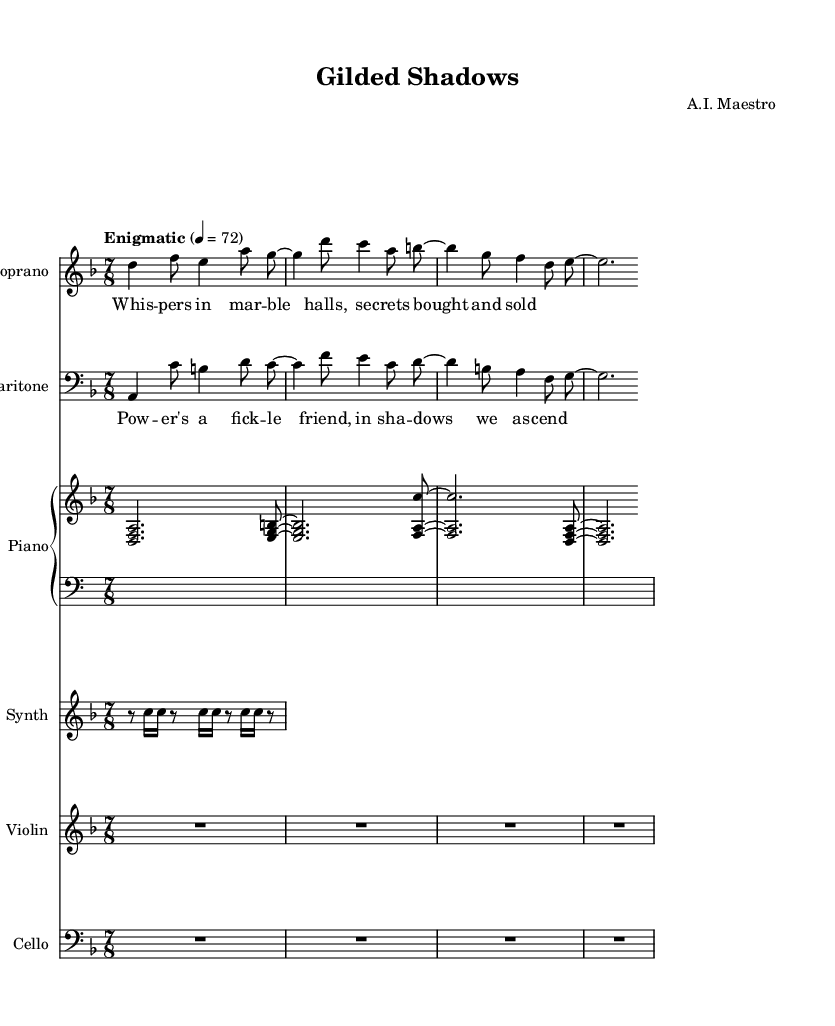What is the key signature of this music? The key signature is indicated by the information "d minor" in the global variable section, which typically outlines the key. D minor has one flat (B flat).
Answer: D minor What is the time signature of this music? The time signature is specified as "7/8" in the global section, which is a compound time signature showing there are seven eighth notes in each measure.
Answer: 7/8 What is the tempo marking for this piece? The tempo marking is found in the global section where it states "Enigmatic" followed by "4 = 72," indicating the speed at which the music should be played.
Answer: Enigmatic 4 = 72 Which instrument has a synthesizer part? By looking into the score structure, the label "Synth" indicates that the synthesizer is specified as one of the instruments included in the score.
Answer: Synthesizer How many measures are in the soprano part? The soprano part consists of a series of measures indicated by the composition; there are 4 measures in total as each section shows distinct groupings separated by bar lines.
Answer: 4 measures What is the theme explored in the lyrics of this opera? The lyrics express themes of power and secrecy, as indicated by the words "Whispers in marble halls, secrets bought and sold," highlighting the intrigue around wealth and power dynamics.
Answer: Wealth, power, and intrigue What is the function of the cello in this orchestration? The cello is notated as a separate staff, suggesting it contributes to the overall harmony and texture of the piece, typical for providing a rich base, and it is marked with a whole rest throughout without content specified.
Answer: Harmony and texture 